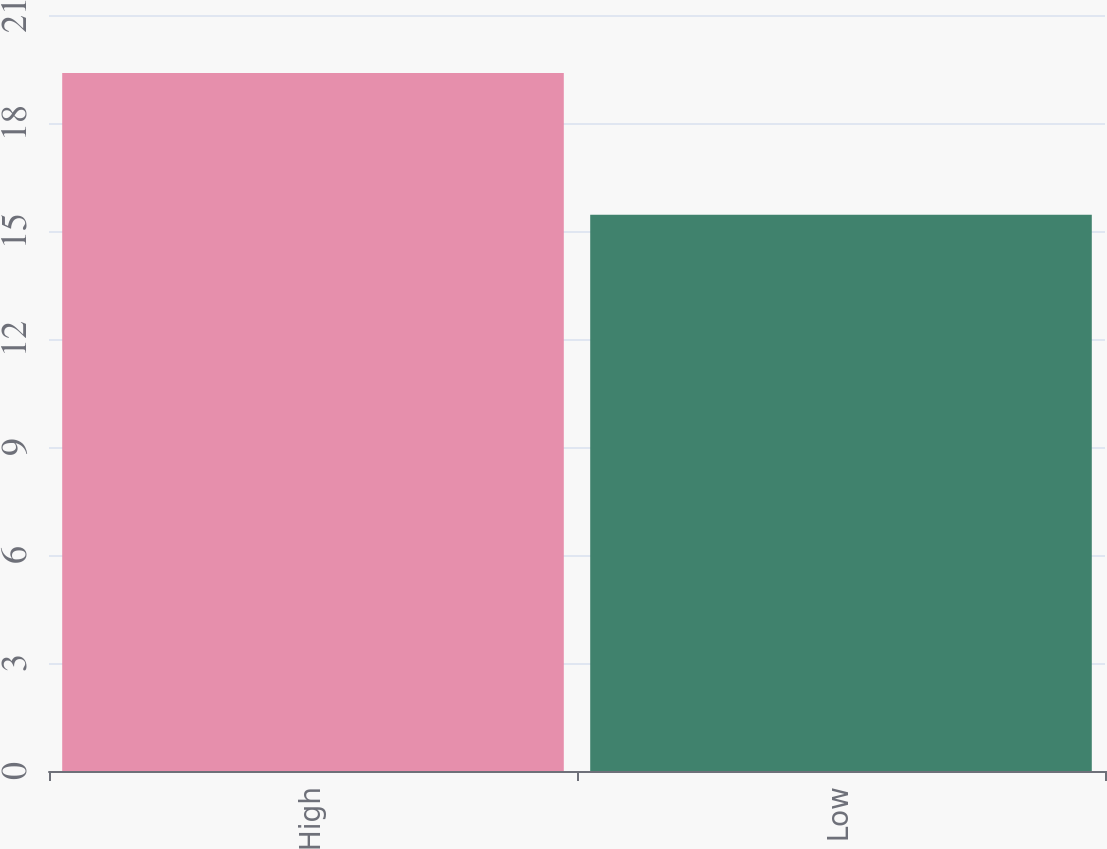Convert chart. <chart><loc_0><loc_0><loc_500><loc_500><bar_chart><fcel>High<fcel>Low<nl><fcel>19.39<fcel>15.45<nl></chart> 